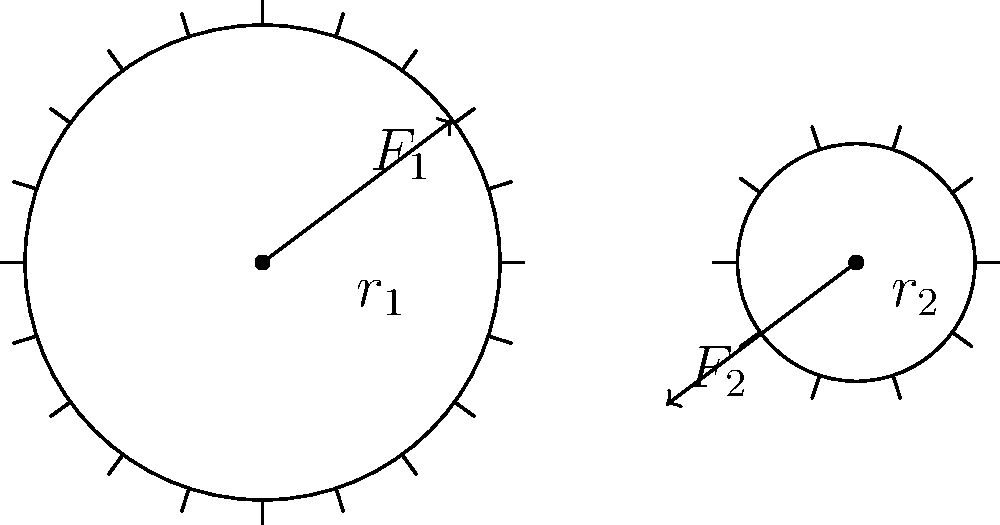In the simple gear train shown, gear 1 (larger) drives gear 2 (smaller). The radius of gear 1 is twice that of gear 2. If a force $F_1$ is applied tangentially to gear 1, causing it to rotate clockwise, what is the magnitude of the resulting force $F_2$ on gear 2 in terms of $F_1$, assuming no energy losses? To solve this problem, we'll use the principle of conservation of energy and the relationship between torque and force in gears. Let's proceed step-by-step:

1) In an ideal gear system (no energy losses), the input power equals the output power:

   $$P_{in} = P_{out}$$

2) Power is the product of torque ($\tau$) and angular velocity ($\omega$):

   $$\tau_1 \omega_1 = \tau_2 \omega_2$$

3) Torque is the product of force and radius:

   $$\tau_1 = F_1 r_1$$ and $$\tau_2 = F_2 r_2$$

4) The ratio of angular velocities is inversely proportional to the ratio of radii:

   $$\frac{\omega_1}{\omega_2} = \frac{r_2}{r_1}$$

5) Substituting these into the power equation:

   $$F_1 r_1 \omega_1 = F_2 r_2 \omega_2$$

6) Given that $r_1 = 2r_2$, we can substitute:

   $$F_1 (2r_2) \frac{\omega_2}{2} = F_2 r_2 \omega_2$$

7) The $r_2$ and $\omega_2$ terms cancel out:

   $$F_1 = F_2$$

Therefore, the magnitude of $F_2$ is equal to $F_1$, despite the difference in gear sizes. This is because the larger gear provides a mechanical advantage in terms of torque, but this is exactly balanced by its lower angular velocity.
Answer: $F_2 = F_1$ 